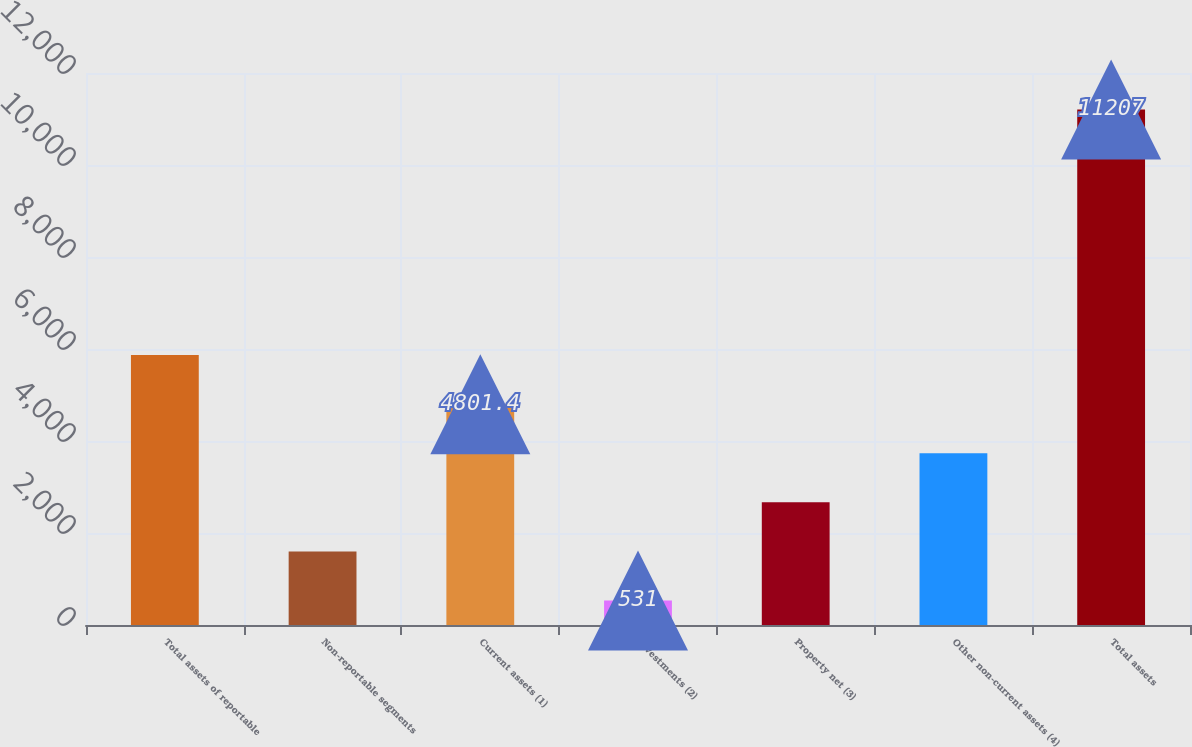<chart> <loc_0><loc_0><loc_500><loc_500><bar_chart><fcel>Total assets of reportable<fcel>Non-reportable segments<fcel>Current assets (1)<fcel>Investments (2)<fcel>Property net (3)<fcel>Other non-current assets (4)<fcel>Total assets<nl><fcel>5869<fcel>1598.6<fcel>4801.4<fcel>531<fcel>2666.2<fcel>3733.8<fcel>11207<nl></chart> 